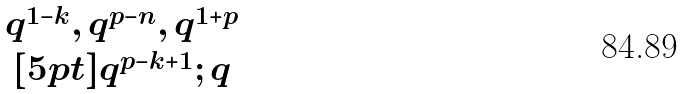<formula> <loc_0><loc_0><loc_500><loc_500>\begin{matrix} q ^ { 1 - k } , q ^ { p - n } , q ^ { 1 + p } \\ [ 5 p t ] q ^ { p - k + 1 } ; q \end{matrix}</formula> 